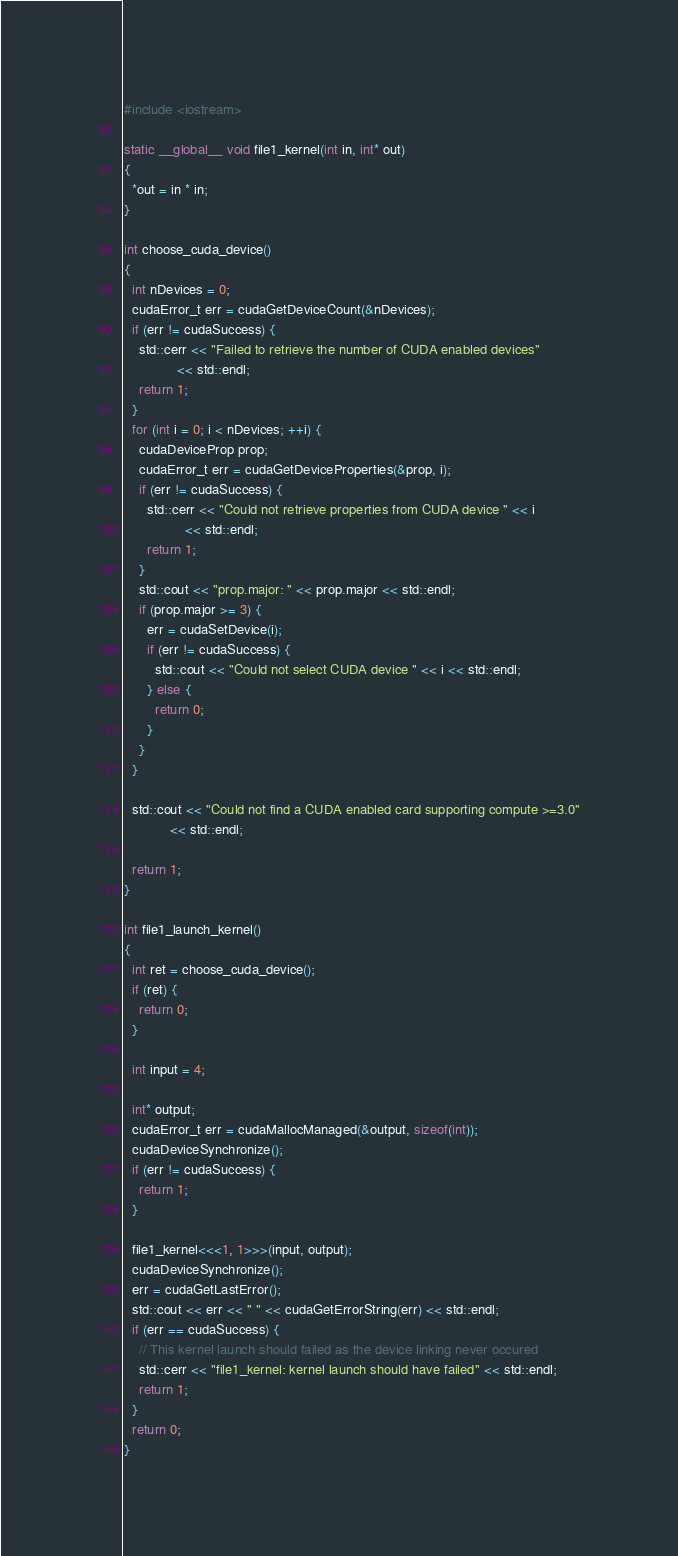<code> <loc_0><loc_0><loc_500><loc_500><_Cuda_>
#include <iostream>

static __global__ void file1_kernel(int in, int* out)
{
  *out = in * in;
}

int choose_cuda_device()
{
  int nDevices = 0;
  cudaError_t err = cudaGetDeviceCount(&nDevices);
  if (err != cudaSuccess) {
    std::cerr << "Failed to retrieve the number of CUDA enabled devices"
              << std::endl;
    return 1;
  }
  for (int i = 0; i < nDevices; ++i) {
    cudaDeviceProp prop;
    cudaError_t err = cudaGetDeviceProperties(&prop, i);
    if (err != cudaSuccess) {
      std::cerr << "Could not retrieve properties from CUDA device " << i
                << std::endl;
      return 1;
    }
    std::cout << "prop.major: " << prop.major << std::endl;
    if (prop.major >= 3) {
      err = cudaSetDevice(i);
      if (err != cudaSuccess) {
        std::cout << "Could not select CUDA device " << i << std::endl;
      } else {
        return 0;
      }
    }
  }

  std::cout << "Could not find a CUDA enabled card supporting compute >=3.0"
            << std::endl;

  return 1;
}

int file1_launch_kernel()
{
  int ret = choose_cuda_device();
  if (ret) {
    return 0;
  }

  int input = 4;

  int* output;
  cudaError_t err = cudaMallocManaged(&output, sizeof(int));
  cudaDeviceSynchronize();
  if (err != cudaSuccess) {
    return 1;
  }

  file1_kernel<<<1, 1>>>(input, output);
  cudaDeviceSynchronize();
  err = cudaGetLastError();
  std::cout << err << " " << cudaGetErrorString(err) << std::endl;
  if (err == cudaSuccess) {
    // This kernel launch should failed as the device linking never occured
    std::cerr << "file1_kernel: kernel launch should have failed" << std::endl;
    return 1;
  }
  return 0;
}
</code> 